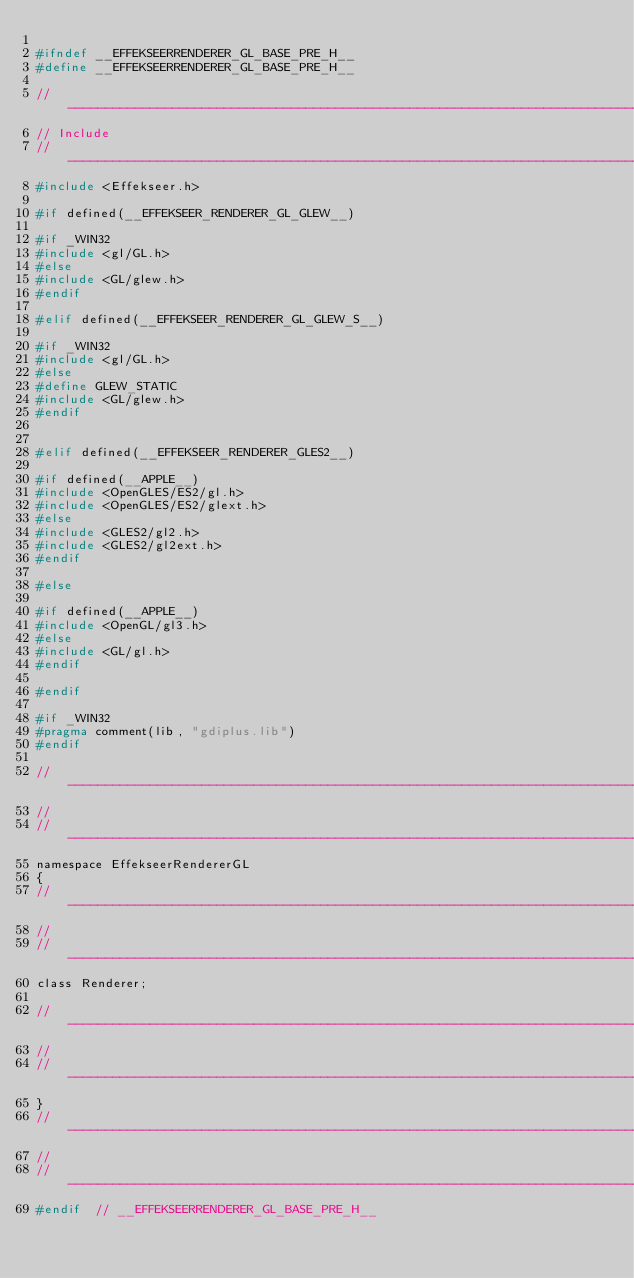<code> <loc_0><loc_0><loc_500><loc_500><_C_>
#ifndef	__EFFEKSEERRENDERER_GL_BASE_PRE_H__
#define	__EFFEKSEERRENDERER_GL_BASE_PRE_H__

//----------------------------------------------------------------------------------
// Include
//----------------------------------------------------------------------------------
#include <Effekseer.h>

#if defined(__EFFEKSEER_RENDERER_GL_GLEW__)

#if _WIN32
#include <gl/GL.h>
#else
#include <GL/glew.h>
#endif

#elif defined(__EFFEKSEER_RENDERER_GL_GLEW_S__)

#if _WIN32
#include <gl/GL.h>
#else
#define GLEW_STATIC
#include <GL/glew.h>
#endif


#elif defined(__EFFEKSEER_RENDERER_GLES2__)

#if defined(__APPLE__)
#include <OpenGLES/ES2/gl.h>
#include <OpenGLES/ES2/glext.h>
#else
#include <GLES2/gl2.h>
#include <GLES2/gl2ext.h>
#endif

#else

#if defined(__APPLE__)
#include <OpenGL/gl3.h>
#else
#include <GL/gl.h>
#endif

#endif

#if _WIN32
#pragma comment(lib, "gdiplus.lib")
#endif

//----------------------------------------------------------------------------------
//
//----------------------------------------------------------------------------------
namespace EffekseerRendererGL
{
//----------------------------------------------------------------------------------
//
//----------------------------------------------------------------------------------
class Renderer;

//----------------------------------------------------------------------------------
//
//----------------------------------------------------------------------------------
}
//----------------------------------------------------------------------------------
//
//----------------------------------------------------------------------------------
#endif	// __EFFEKSEERRENDERER_GL_BASE_PRE_H__
</code> 